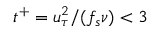Convert formula to latex. <formula><loc_0><loc_0><loc_500><loc_500>t ^ { + } = u _ { \tau } ^ { 2 } / ( f _ { s } \nu ) < 3</formula> 